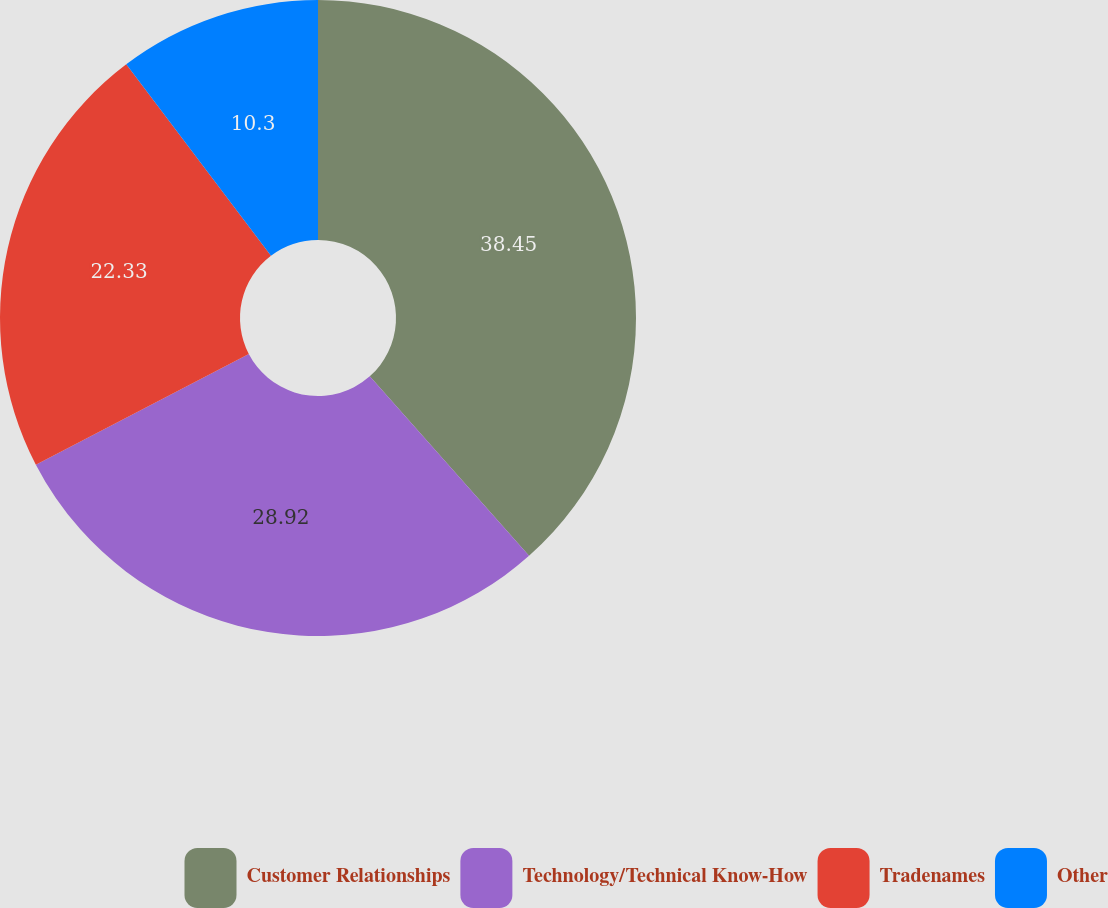Convert chart. <chart><loc_0><loc_0><loc_500><loc_500><pie_chart><fcel>Customer Relationships<fcel>Technology/Technical Know-How<fcel>Tradenames<fcel>Other<nl><fcel>38.45%<fcel>28.92%<fcel>22.33%<fcel>10.3%<nl></chart> 